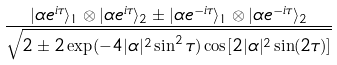Convert formula to latex. <formula><loc_0><loc_0><loc_500><loc_500>\frac { | \alpha e ^ { i \tau } \rangle _ { 1 } \otimes | \alpha e ^ { i \tau } \rangle _ { 2 } \pm | \alpha e ^ { - i \tau } \rangle _ { 1 } \otimes | \alpha e ^ { - i \tau } \rangle _ { 2 } } { \sqrt { 2 \pm 2 \exp ( - 4 | \alpha | ^ { 2 } \sin ^ { 2 } \tau ) \cos [ 2 | \alpha | ^ { 2 } \sin ( 2 \tau ) ] } }</formula> 